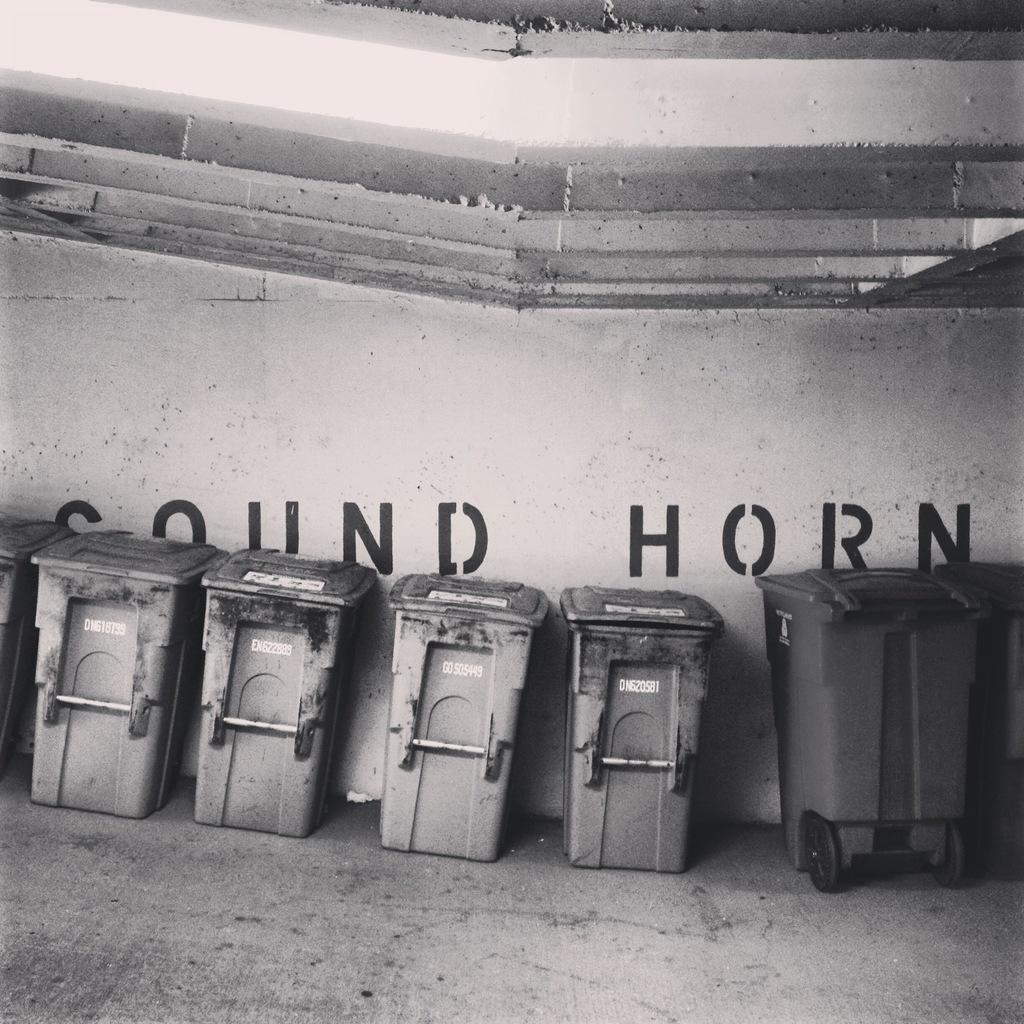Provide a one-sentence caption for the provided image. Garbage pails are lined up in front of a wall that says sound horn on it. 